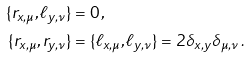Convert formula to latex. <formula><loc_0><loc_0><loc_500><loc_500>\{ r _ { x , \mu } , \ell _ { y , \nu } \} & = 0 \, , \\ \{ r _ { x , \mu } , r _ { y , \nu } \} & = \{ \ell _ { x , \mu } , \ell _ { y , \nu } \} = 2 \delta _ { x , y } \delta _ { \mu , \nu } \, .</formula> 